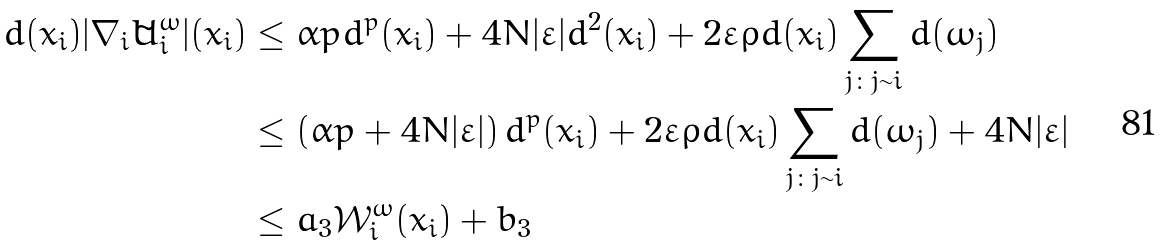Convert formula to latex. <formula><loc_0><loc_0><loc_500><loc_500>d ( x _ { i } ) | \nabla _ { i } \tilde { U } ^ { \omega } _ { i } | ( x _ { i } ) & \leq \alpha p d ^ { p } ( x _ { i } ) + 4 N | \varepsilon | d ^ { 2 } ( x _ { i } ) + 2 \varepsilon \rho d ( x _ { i } ) \sum _ { j \colon j \sim i } d ( \omega _ { j } ) \\ & \leq \left ( \alpha p + 4 N | \varepsilon | \right ) d ^ { p } ( x _ { i } ) + 2 \varepsilon \rho d ( x _ { i } ) \sum _ { j \colon j \sim i } d ( \omega _ { j } ) + 4 N | \varepsilon | \\ & \leq a _ { 3 } \mathcal { W } _ { i } ^ { \omega } ( x _ { i } ) + b _ { 3 }</formula> 